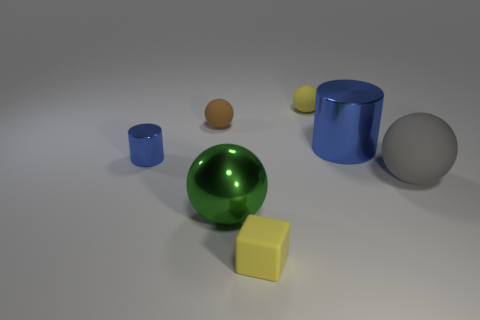How big is the metal cylinder in front of the large shiny thing behind the gray matte thing?
Offer a terse response. Small. Are there any other things that have the same material as the brown thing?
Offer a terse response. Yes. Are there more small brown matte things than blue metallic objects?
Offer a terse response. No. Does the rubber sphere that is to the right of the small yellow rubber ball have the same color as the large sphere that is on the left side of the large metallic cylinder?
Your answer should be compact. No. Is there a small rubber thing that is in front of the metallic object that is to the right of the yellow block?
Your answer should be compact. Yes. Is the number of small metallic cylinders in front of the small blue metallic cylinder less than the number of small rubber objects that are in front of the large green ball?
Keep it short and to the point. Yes. Do the cylinder right of the brown object and the big thing right of the big metallic cylinder have the same material?
Keep it short and to the point. No. What number of tiny objects are green shiny things or cyan cylinders?
Offer a terse response. 0. There is a tiny blue thing that is the same material as the large blue cylinder; what is its shape?
Provide a succinct answer. Cylinder. Is the number of metallic cylinders in front of the large metal cylinder less than the number of cubes?
Ensure brevity in your answer.  No. 